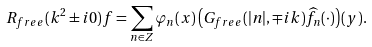Convert formula to latex. <formula><loc_0><loc_0><loc_500><loc_500>R _ { f r e e } ( k ^ { 2 } \pm i 0 ) f = \sum _ { n \in { Z } } \varphi _ { n } ( x ) \left ( G _ { f r e e } ( | n | , \mp i k ) \widehat { f } _ { n } ( \cdot ) \right ) ( y ) .</formula> 